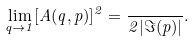Convert formula to latex. <formula><loc_0><loc_0><loc_500><loc_500>\lim _ { q \rightarrow 1 } [ A ( q , p ) ] ^ { 2 } = \frac { } { 2 | \Im ( p ) | } .</formula> 